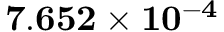<formula> <loc_0><loc_0><loc_500><loc_500>7 . 6 5 2 \times 1 0 ^ { - 4 }</formula> 